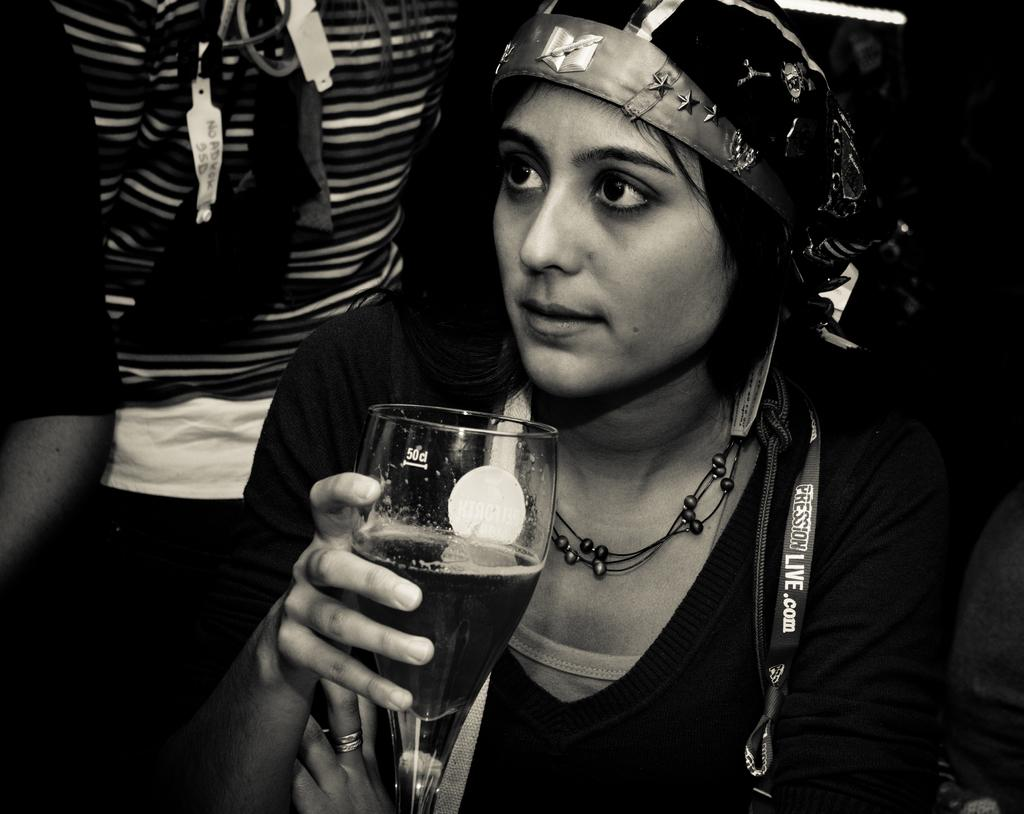What is the person in the image doing? The person in the image is sitting. What is the person holding in the image? The person is holding a glass. Are there any other people in the image? Yes, there are other people standing in the image. What type of fog can be seen in the image? There is no fog present in the image. What achievements has the person sitting in the image accomplished? The image does not provide information about the person's achievements. 